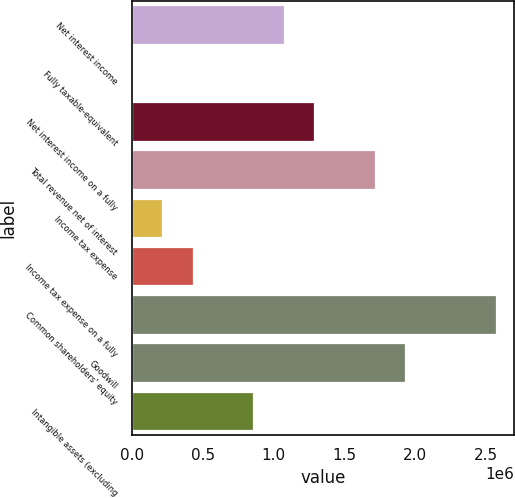Convert chart to OTSL. <chart><loc_0><loc_0><loc_500><loc_500><bar_chart><fcel>Net interest income<fcel>Fully taxable-equivalent<fcel>Net interest income on a fully<fcel>Total revenue net of interest<fcel>Income tax expense<fcel>Income tax expense on a fully<fcel>Common shareholders' equity<fcel>Goodwill<fcel>Intangible assets (excluding<nl><fcel>1.07226e+06<fcel>225<fcel>1.28666e+06<fcel>1.71547e+06<fcel>214631<fcel>429037<fcel>2.5731e+06<fcel>1.92988e+06<fcel>857850<nl></chart> 